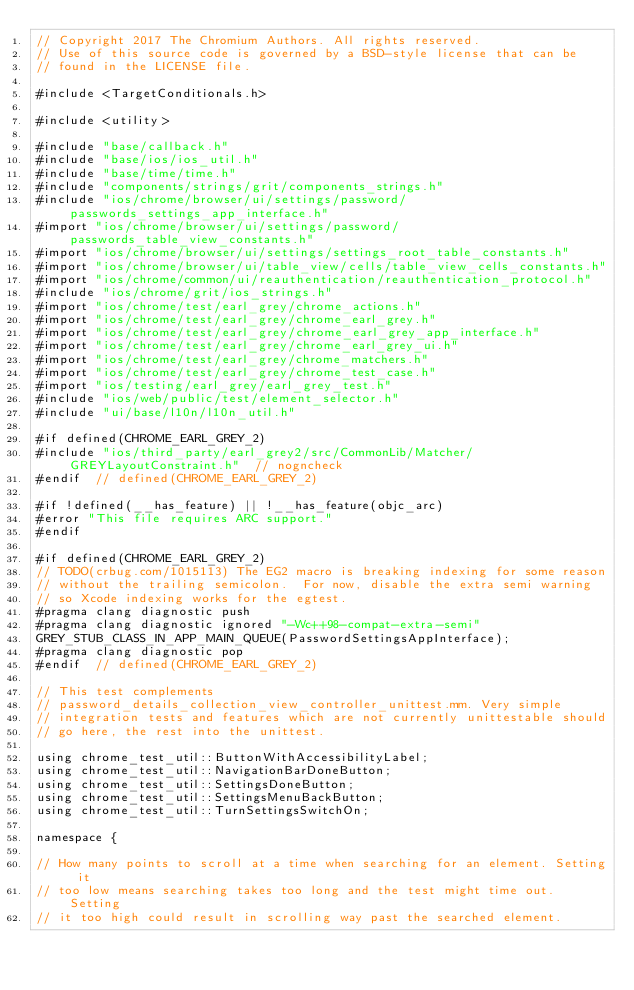<code> <loc_0><loc_0><loc_500><loc_500><_ObjectiveC_>// Copyright 2017 The Chromium Authors. All rights reserved.
// Use of this source code is governed by a BSD-style license that can be
// found in the LICENSE file.

#include <TargetConditionals.h>

#include <utility>

#include "base/callback.h"
#include "base/ios/ios_util.h"
#include "base/time/time.h"
#include "components/strings/grit/components_strings.h"
#include "ios/chrome/browser/ui/settings/password/passwords_settings_app_interface.h"
#import "ios/chrome/browser/ui/settings/password/passwords_table_view_constants.h"
#import "ios/chrome/browser/ui/settings/settings_root_table_constants.h"
#import "ios/chrome/browser/ui/table_view/cells/table_view_cells_constants.h"
#import "ios/chrome/common/ui/reauthentication/reauthentication_protocol.h"
#include "ios/chrome/grit/ios_strings.h"
#import "ios/chrome/test/earl_grey/chrome_actions.h"
#import "ios/chrome/test/earl_grey/chrome_earl_grey.h"
#import "ios/chrome/test/earl_grey/chrome_earl_grey_app_interface.h"
#import "ios/chrome/test/earl_grey/chrome_earl_grey_ui.h"
#import "ios/chrome/test/earl_grey/chrome_matchers.h"
#import "ios/chrome/test/earl_grey/chrome_test_case.h"
#import "ios/testing/earl_grey/earl_grey_test.h"
#include "ios/web/public/test/element_selector.h"
#include "ui/base/l10n/l10n_util.h"

#if defined(CHROME_EARL_GREY_2)
#include "ios/third_party/earl_grey2/src/CommonLib/Matcher/GREYLayoutConstraint.h"  // nogncheck
#endif  // defined(CHROME_EARL_GREY_2)

#if !defined(__has_feature) || !__has_feature(objc_arc)
#error "This file requires ARC support."
#endif

#if defined(CHROME_EARL_GREY_2)
// TODO(crbug.com/1015113) The EG2 macro is breaking indexing for some reason
// without the trailing semicolon.  For now, disable the extra semi warning
// so Xcode indexing works for the egtest.
#pragma clang diagnostic push
#pragma clang diagnostic ignored "-Wc++98-compat-extra-semi"
GREY_STUB_CLASS_IN_APP_MAIN_QUEUE(PasswordSettingsAppInterface);
#pragma clang diagnostic pop
#endif  // defined(CHROME_EARL_GREY_2)

// This test complements
// password_details_collection_view_controller_unittest.mm. Very simple
// integration tests and features which are not currently unittestable should
// go here, the rest into the unittest.

using chrome_test_util::ButtonWithAccessibilityLabel;
using chrome_test_util::NavigationBarDoneButton;
using chrome_test_util::SettingsDoneButton;
using chrome_test_util::SettingsMenuBackButton;
using chrome_test_util::TurnSettingsSwitchOn;

namespace {

// How many points to scroll at a time when searching for an element. Setting it
// too low means searching takes too long and the test might time out. Setting
// it too high could result in scrolling way past the searched element.</code> 